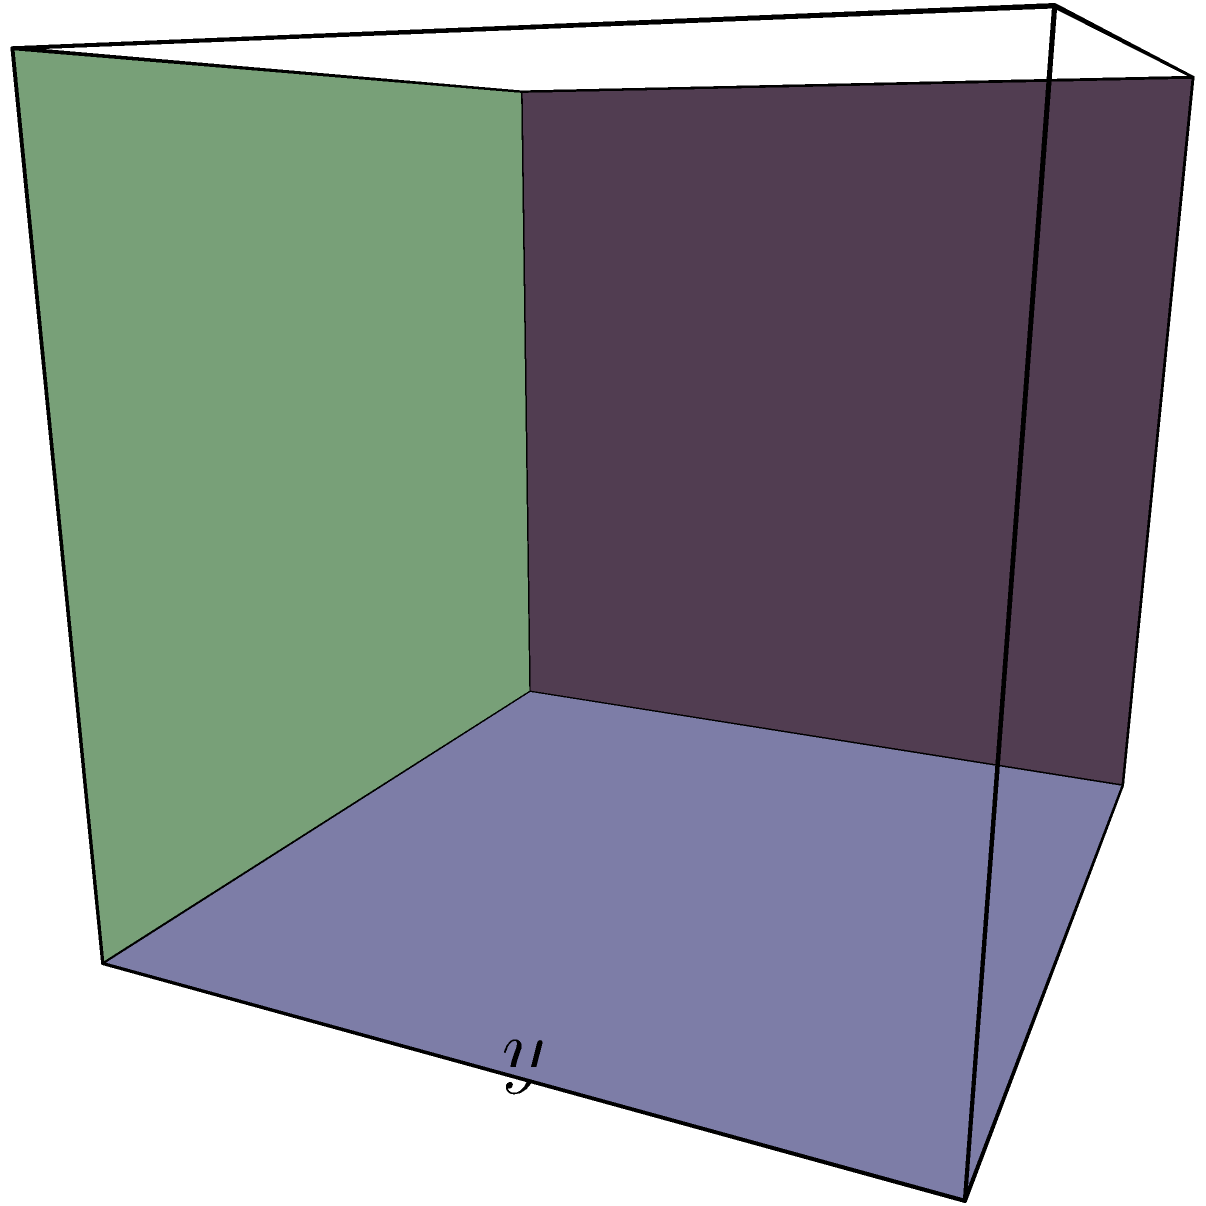A rectangular box without a lid is to be constructed from a piece of cardboard with a surface area of 108 square inches. What dimensions will maximize the volume of the box? Let's approach this step-by-step:

1) Let $x$, $y$, and $z$ be the length, width, and height of the box respectively.

2) The surface area of the box (without the top) is given by:
   $$ SA = xy + 2xz + 2yz = 108 $$

3) The volume of the box is:
   $$ V = xyz $$

4) From the surface area equation, we can express $y$ in terms of $x$ and $z$:
   $$ y = \frac{108 - 2xz}{x + 2z} $$

5) Substituting this into the volume equation:
   $$ V = xz \cdot \frac{108 - 2xz}{x + 2z} $$

6) To find the maximum volume, we need to find the partial derivatives with respect to $x$ and $z$ and set them to zero:

   $\frac{\partial V}{\partial x} = 0$ and $\frac{\partial V}{\partial z} = 0$

7) Solving these equations (which is quite complex), we find that the maximum occurs when:
   $$ x = z = 6 \text{ inches} $$

8) Substituting these values back into the equation for $y$:
   $$ y = \frac{108 - 2(6)(6)}{6 + 2(6)} = \frac{36}{18} = 2 \text{ inches} $$

Therefore, the dimensions that maximize the volume are 6 inches × 2 inches × 6 inches.
Answer: 6 in × 2 in × 6 in 